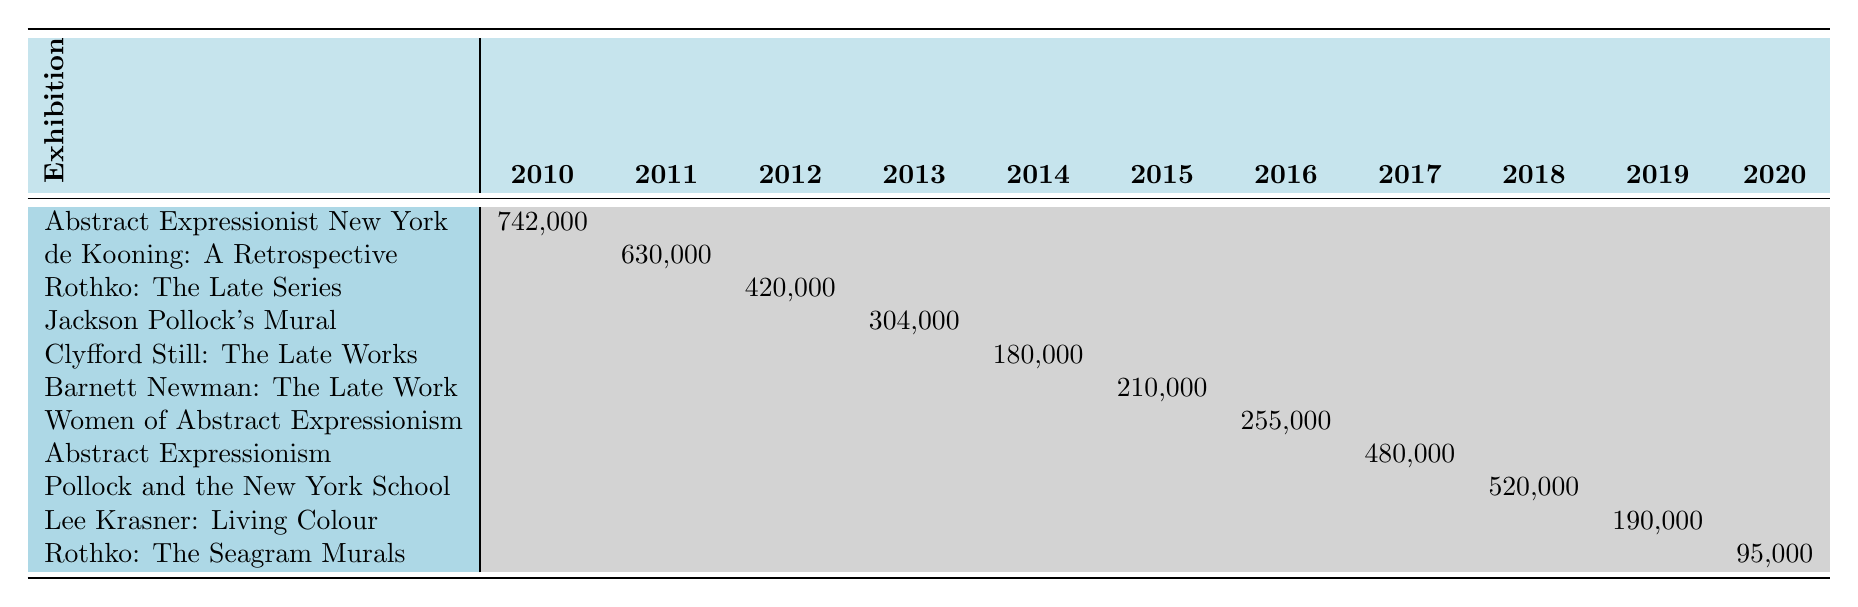What was the highest attendance for an abstract expressionism exhibition during the years 2010 to 2020? Looking at the attendance figures, the highest attendance was for the "Abstract Expressionist New York" exhibition at MoMA in 2010, which had 742,000 attendees.
Answer: 742,000 Which exhibition had the lowest attendance recorded? The "Rothko: The Seagram Murals" exhibition at the National Gallery of Art had the lowest attendance recorded with only 95,000 attendees in 2020.
Answer: 95,000 In which year did the "de Kooning: A Retrospective" exhibition take place? The "de Kooning: A Retrospective" exhibition took place in 2011, with an attendance of 630,000 that year.
Answer: 2011 How many exhibitions had an attendance of over 200,000? There were three exhibitions with an attendance of over 200,000: "Abstract Expressionist New York" (742,000), "de Kooning: A Retrospective" (630,000), and "Barnett Newman: The Late Work" (210,000).
Answer: 3 What was the total attendance for exhibitions at the Denver Art Museum? The total attendance for the Denver Art Museum’s exhibitions is 180,000 ("Clyfford Still: The Late Works") plus 255,000 ("Women of Abstract Expressionism"), which sums to 435,000.
Answer: 435,000 Was there any exhibition in 2017, and if so, which one? Yes, there was one exhibition in 2017: "Women of Abstract Expressionism" at the Denver Art Museum, which drew 255,000 attendees.
Answer: Yes, "Women of Abstract Expressionism" What is the average attendance for the exhibitions held at MoMA? The exhibitions at MoMA are "Abstract Expressionist New York" (742,000) in 2010 and "de Kooning: A Retrospective" (630,000) in 2011. The average attendance is (742,000 + 630,000) / 2 = 686,000.
Answer: 686,000 Which exhibition had the largest attendance gap between its best and worst year? The "Abstract Expressionist New York" exhibition had a best year attendance of 742,000 in 2010 and a worst year of 0 in the following years, leading to a gap of 742,000.
Answer: 742,000 What was the total attendance of all exhibitions in 2019? The total attendance in 2019 includes "Pollock and the New York School" (520,000) and "Lee Krasner: Living Colour" (190,000), and "Rothko: The Seagram Murals" (0) which sums up to 710,000.
Answer: 710,000 How many different museums hosted exhibitions between 2010 and 2020? There are seven different museums that hosted exhibitions: MoMA, Tate Modern, Getty Center, Denver Art Museum, Philadelphia Museum of Art, Royal Academy of Arts, Guggenheim Museum, Barbican Art Gallery, and National Gallery of Art.
Answer: 9 Did any exhibition have a consistent attendance each year it was held? No, all exhibitions showed attendance in a non-consistent manner, only appearing in single years without repeat attendance figures.
Answer: No 